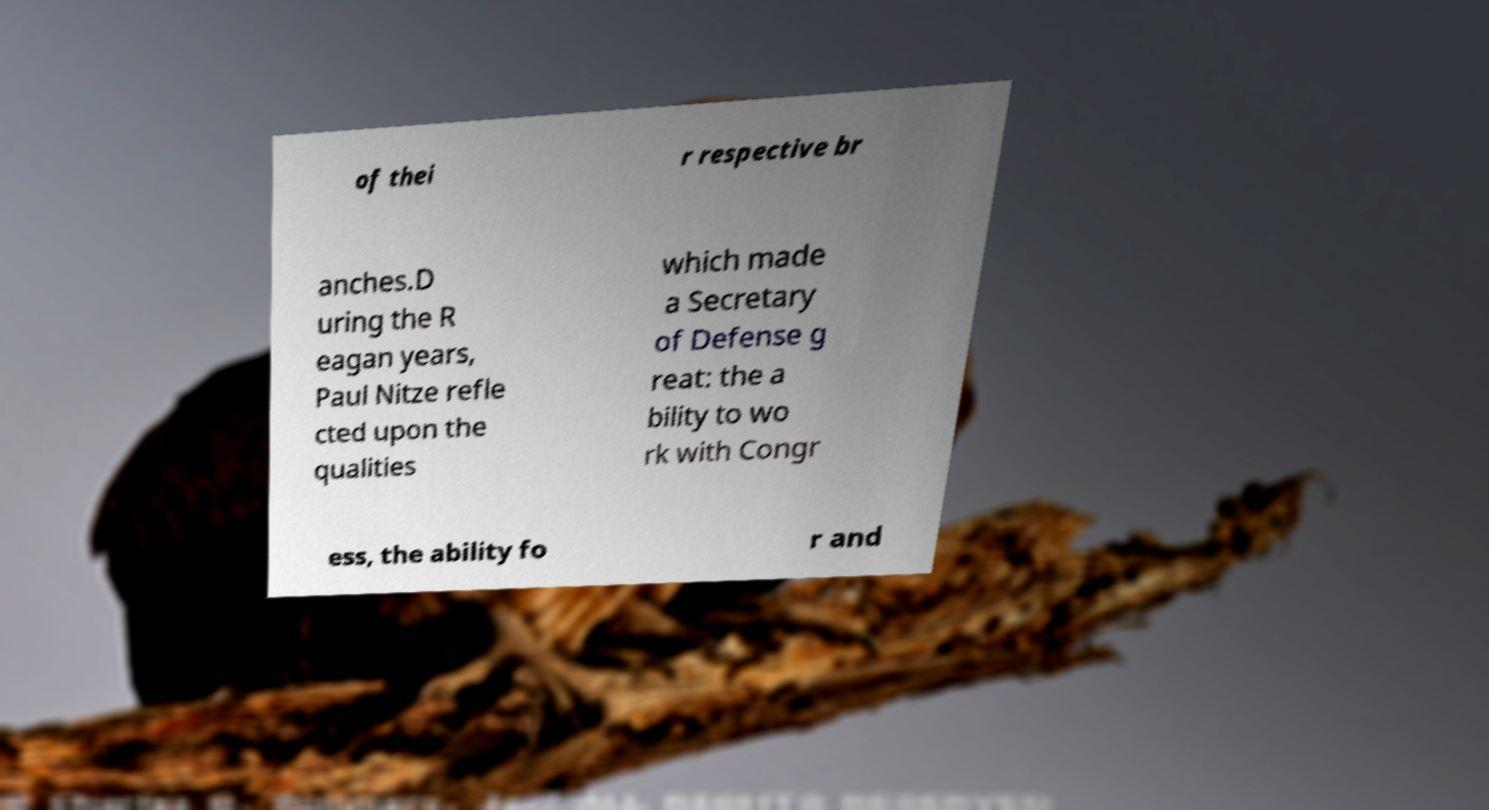Could you extract and type out the text from this image? of thei r respective br anches.D uring the R eagan years, Paul Nitze refle cted upon the qualities which made a Secretary of Defense g reat: the a bility to wo rk with Congr ess, the ability fo r and 